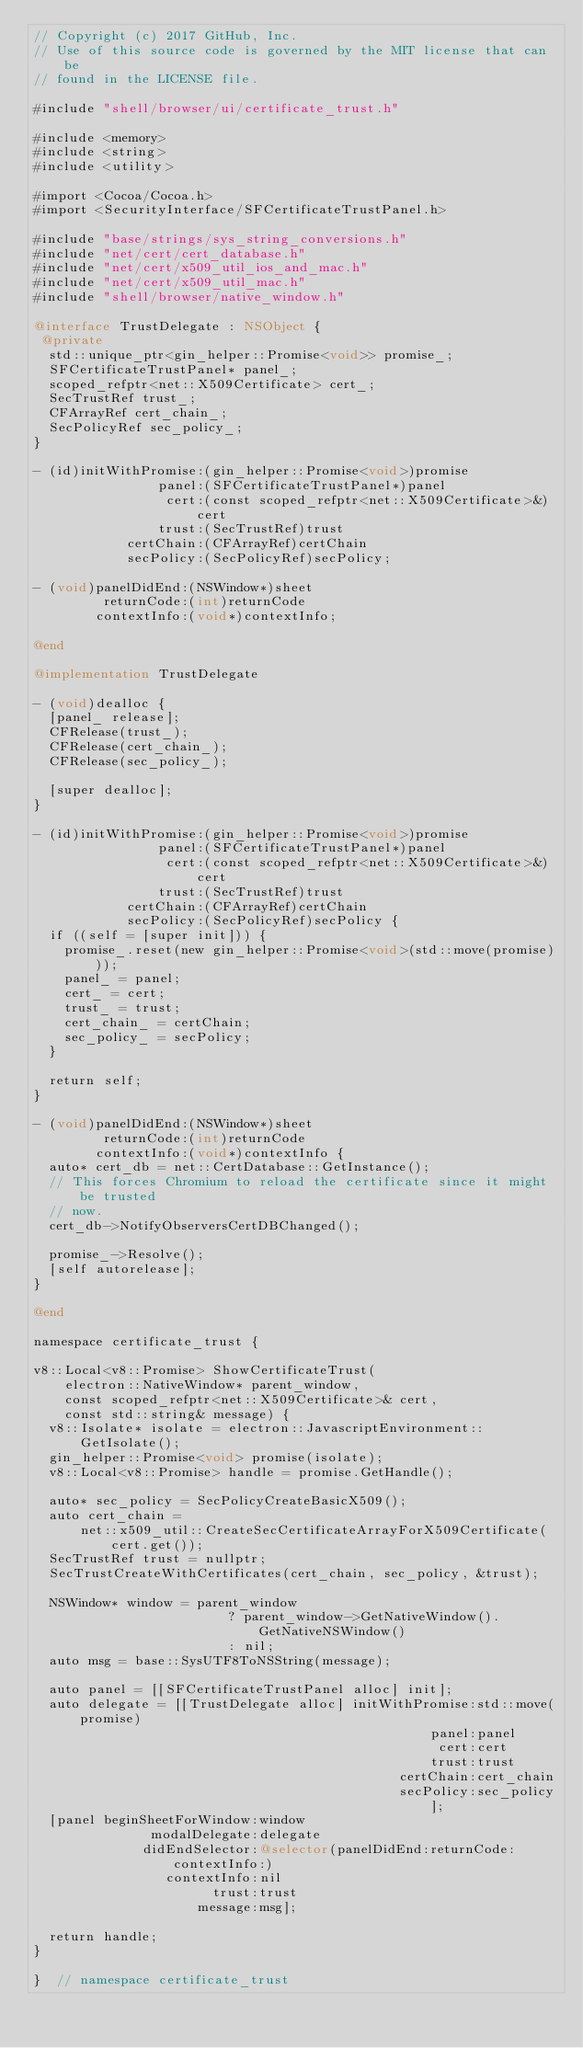Convert code to text. <code><loc_0><loc_0><loc_500><loc_500><_ObjectiveC_>// Copyright (c) 2017 GitHub, Inc.
// Use of this source code is governed by the MIT license that can be
// found in the LICENSE file.

#include "shell/browser/ui/certificate_trust.h"

#include <memory>
#include <string>
#include <utility>

#import <Cocoa/Cocoa.h>
#import <SecurityInterface/SFCertificateTrustPanel.h>

#include "base/strings/sys_string_conversions.h"
#include "net/cert/cert_database.h"
#include "net/cert/x509_util_ios_and_mac.h"
#include "net/cert/x509_util_mac.h"
#include "shell/browser/native_window.h"

@interface TrustDelegate : NSObject {
 @private
  std::unique_ptr<gin_helper::Promise<void>> promise_;
  SFCertificateTrustPanel* panel_;
  scoped_refptr<net::X509Certificate> cert_;
  SecTrustRef trust_;
  CFArrayRef cert_chain_;
  SecPolicyRef sec_policy_;
}

- (id)initWithPromise:(gin_helper::Promise<void>)promise
                panel:(SFCertificateTrustPanel*)panel
                 cert:(const scoped_refptr<net::X509Certificate>&)cert
                trust:(SecTrustRef)trust
            certChain:(CFArrayRef)certChain
            secPolicy:(SecPolicyRef)secPolicy;

- (void)panelDidEnd:(NSWindow*)sheet
         returnCode:(int)returnCode
        contextInfo:(void*)contextInfo;

@end

@implementation TrustDelegate

- (void)dealloc {
  [panel_ release];
  CFRelease(trust_);
  CFRelease(cert_chain_);
  CFRelease(sec_policy_);

  [super dealloc];
}

- (id)initWithPromise:(gin_helper::Promise<void>)promise
                panel:(SFCertificateTrustPanel*)panel
                 cert:(const scoped_refptr<net::X509Certificate>&)cert
                trust:(SecTrustRef)trust
            certChain:(CFArrayRef)certChain
            secPolicy:(SecPolicyRef)secPolicy {
  if ((self = [super init])) {
    promise_.reset(new gin_helper::Promise<void>(std::move(promise)));
    panel_ = panel;
    cert_ = cert;
    trust_ = trust;
    cert_chain_ = certChain;
    sec_policy_ = secPolicy;
  }

  return self;
}

- (void)panelDidEnd:(NSWindow*)sheet
         returnCode:(int)returnCode
        contextInfo:(void*)contextInfo {
  auto* cert_db = net::CertDatabase::GetInstance();
  // This forces Chromium to reload the certificate since it might be trusted
  // now.
  cert_db->NotifyObserversCertDBChanged();

  promise_->Resolve();
  [self autorelease];
}

@end

namespace certificate_trust {

v8::Local<v8::Promise> ShowCertificateTrust(
    electron::NativeWindow* parent_window,
    const scoped_refptr<net::X509Certificate>& cert,
    const std::string& message) {
  v8::Isolate* isolate = electron::JavascriptEnvironment::GetIsolate();
  gin_helper::Promise<void> promise(isolate);
  v8::Local<v8::Promise> handle = promise.GetHandle();

  auto* sec_policy = SecPolicyCreateBasicX509();
  auto cert_chain =
      net::x509_util::CreateSecCertificateArrayForX509Certificate(cert.get());
  SecTrustRef trust = nullptr;
  SecTrustCreateWithCertificates(cert_chain, sec_policy, &trust);

  NSWindow* window = parent_window
                         ? parent_window->GetNativeWindow().GetNativeNSWindow()
                         : nil;
  auto msg = base::SysUTF8ToNSString(message);

  auto panel = [[SFCertificateTrustPanel alloc] init];
  auto delegate = [[TrustDelegate alloc] initWithPromise:std::move(promise)
                                                   panel:panel
                                                    cert:cert
                                                   trust:trust
                                               certChain:cert_chain
                                               secPolicy:sec_policy];
  [panel beginSheetForWindow:window
               modalDelegate:delegate
              didEndSelector:@selector(panelDidEnd:returnCode:contextInfo:)
                 contextInfo:nil
                       trust:trust
                     message:msg];

  return handle;
}

}  // namespace certificate_trust
</code> 